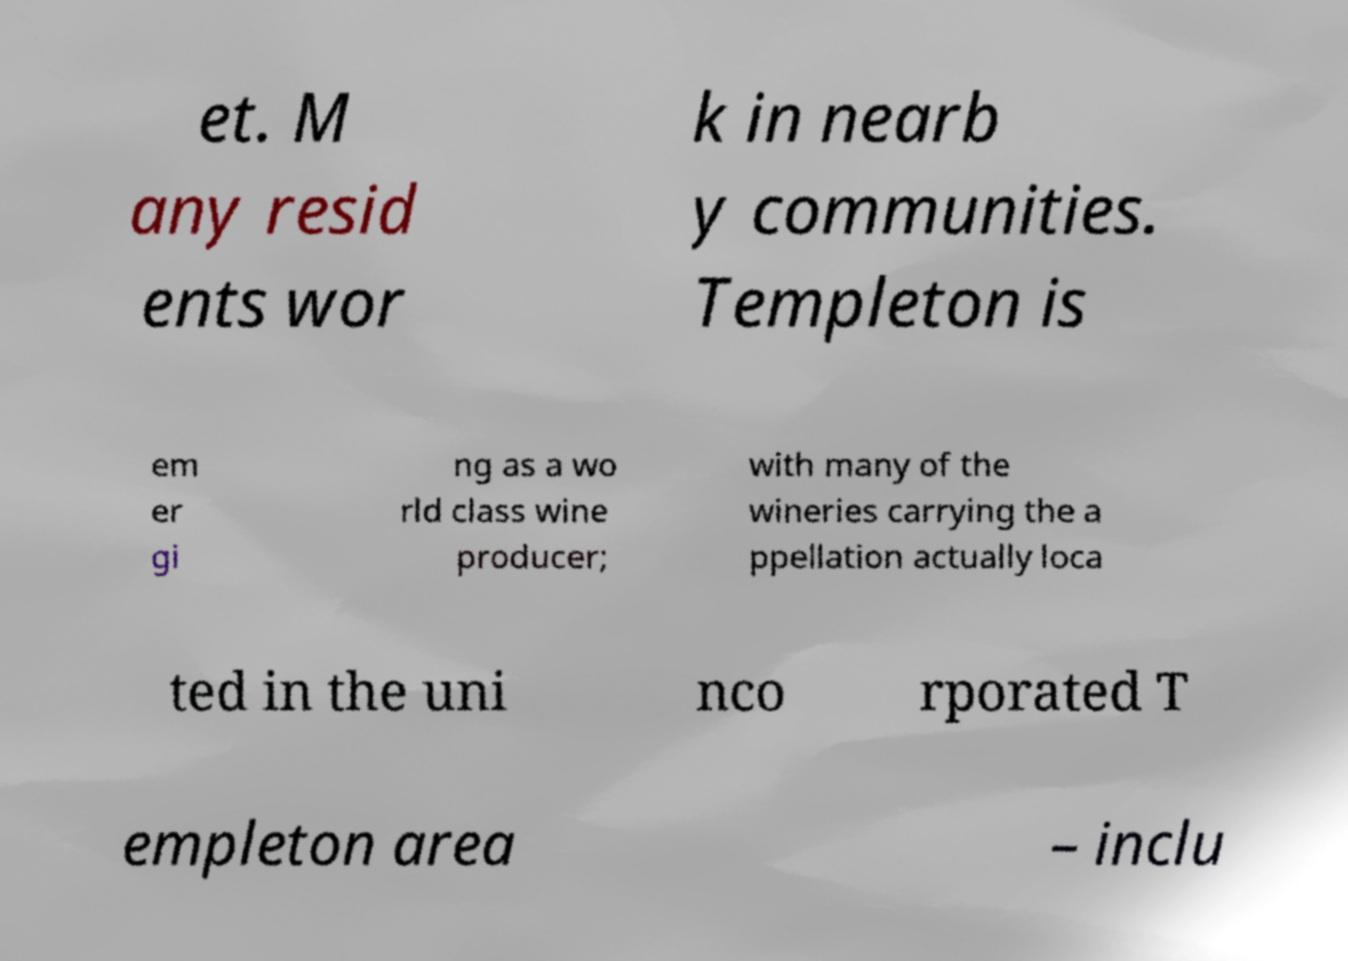There's text embedded in this image that I need extracted. Can you transcribe it verbatim? et. M any resid ents wor k in nearb y communities. Templeton is em er gi ng as a wo rld class wine producer; with many of the wineries carrying the a ppellation actually loca ted in the uni nco rporated T empleton area – inclu 